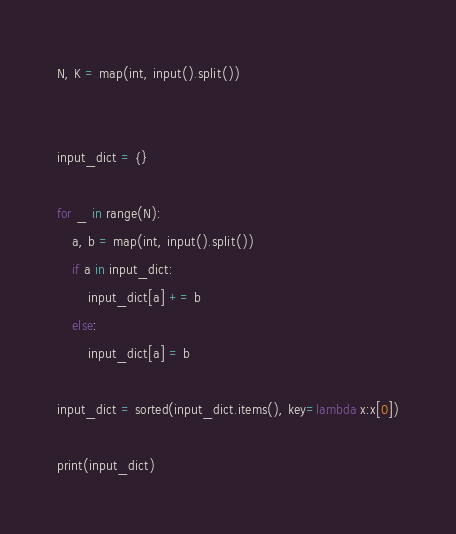<code> <loc_0><loc_0><loc_500><loc_500><_Python_>N, K = map(int, input().split())


input_dict = {}

for _ in range(N):
    a, b = map(int, input().split())
    if a in input_dict:
        input_dict[a] += b
    else:
        input_dict[a] = b

input_dict = sorted(input_dict.items(), key=lambda x:x[0])

print(input_dict)
</code> 